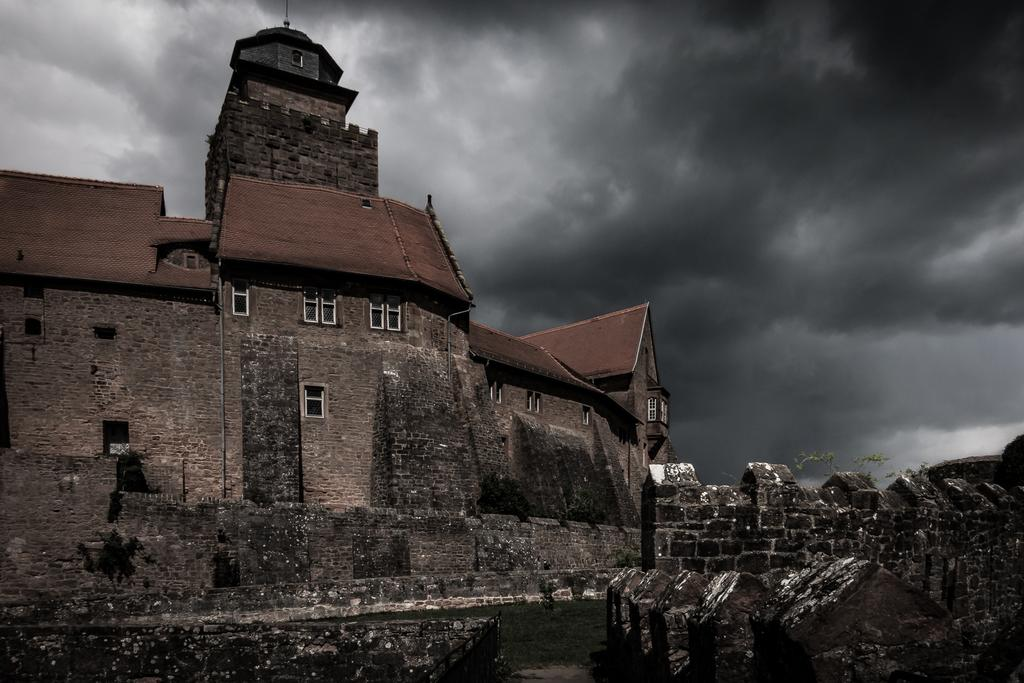What is located at the bottom of the image? There are walls at the bottom of the image. What can be seen in the background of the image? There are buildings, windows, roofs, and clouds visible in the background. Where is the plant located in the image? The plant is on the right side of the image. How many eyes can be seen on the plant in the image? Plants do not have eyes, so there are no eyes visible on the plant in the image. What type of cord is connected to the buildings in the image? There is no cord visible in the image; it only shows buildings, windows, roofs, clouds, and a plant. 